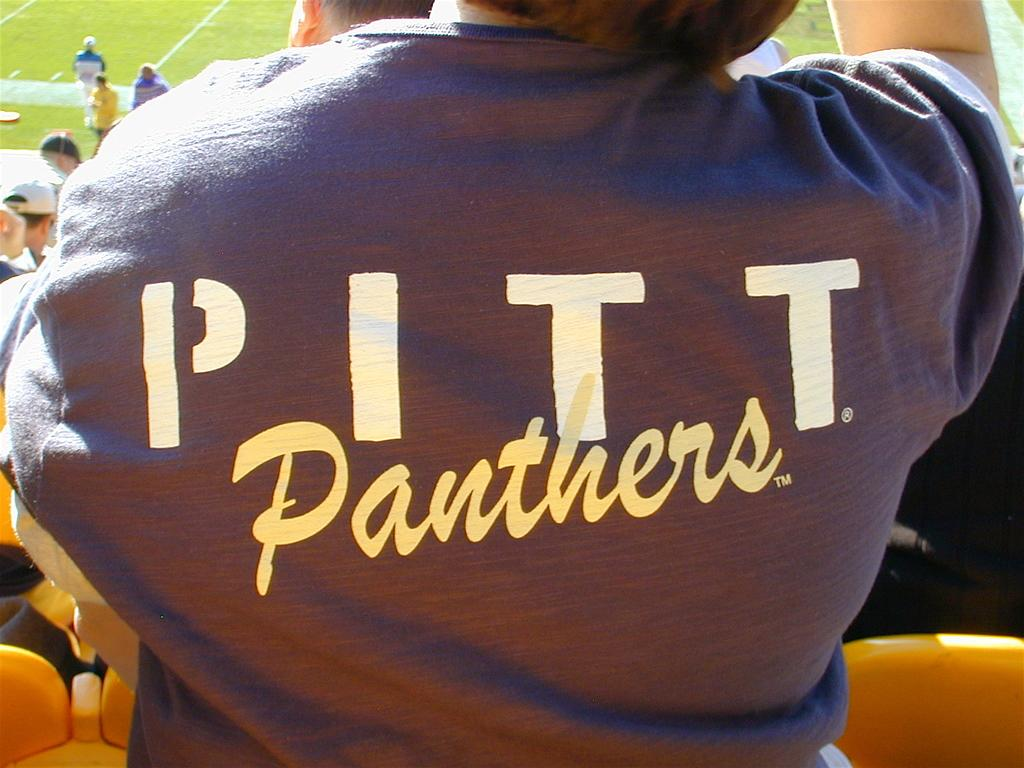<image>
Create a compact narrative representing the image presented. Woman wearing a shirt that says Pitt Panthers sweatshirt at a football game. 